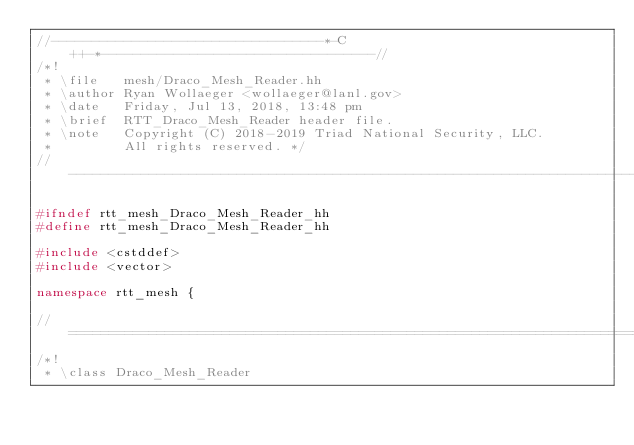<code> <loc_0><loc_0><loc_500><loc_500><_C++_>//----------------------------------*-C++-*----------------------------------//
/*!
 * \file   mesh/Draco_Mesh_Reader.hh
 * \author Ryan Wollaeger <wollaeger@lanl.gov>
 * \date   Friday, Jul 13, 2018, 13:48 pm
 * \brief  RTT_Draco_Mesh_Reader header file.
 * \note   Copyright (C) 2018-2019 Triad National Security, LLC.
 *         All rights reserved. */
//---------------------------------------------------------------------------//

#ifndef rtt_mesh_Draco_Mesh_Reader_hh
#define rtt_mesh_Draco_Mesh_Reader_hh

#include <cstddef>
#include <vector>

namespace rtt_mesh {

//===========================================================================//
/*!
 * \class Draco_Mesh_Reader</code> 